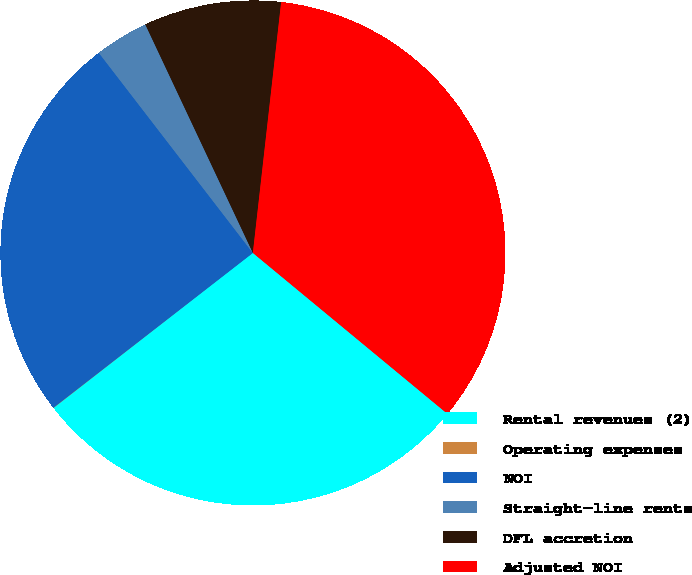Convert chart to OTSL. <chart><loc_0><loc_0><loc_500><loc_500><pie_chart><fcel>Rental revenues (2)<fcel>Operating expenses<fcel>NOI<fcel>Straight-line rents<fcel>DFL accretion<fcel>Adjusted NOI<nl><fcel>28.48%<fcel>0.02%<fcel>25.06%<fcel>3.44%<fcel>8.79%<fcel>34.21%<nl></chart> 